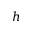<formula> <loc_0><loc_0><loc_500><loc_500>h</formula> 